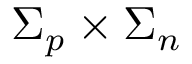<formula> <loc_0><loc_0><loc_500><loc_500>\Sigma _ { p } \times \Sigma _ { n }</formula> 